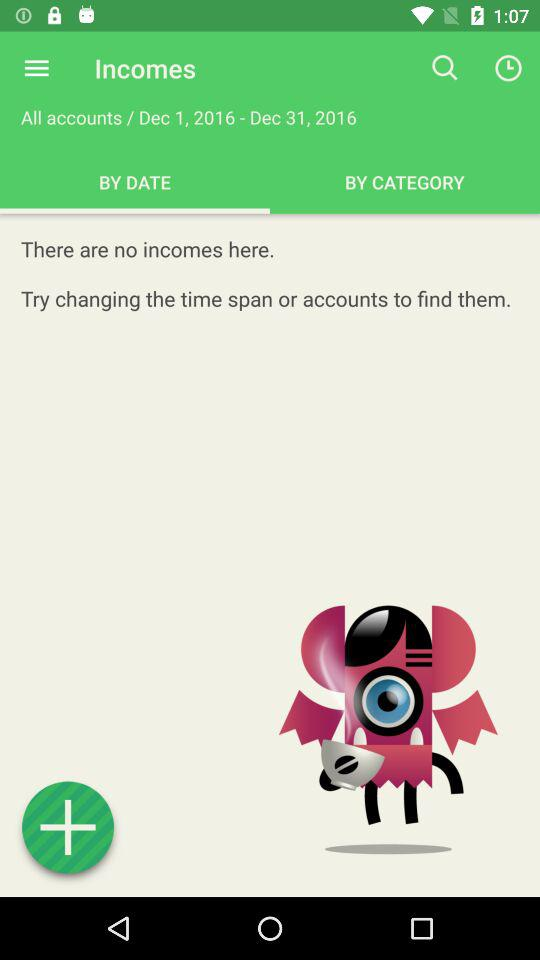Is there any income? There is no income. 